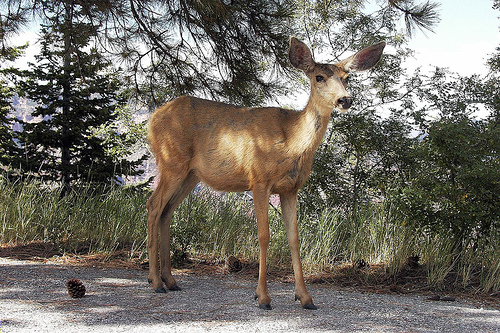<image>
Is the deer next to the pinecone? Yes. The deer is positioned adjacent to the pinecone, located nearby in the same general area. Is there a deer behind the plant? No. The deer is not behind the plant. From this viewpoint, the deer appears to be positioned elsewhere in the scene. 